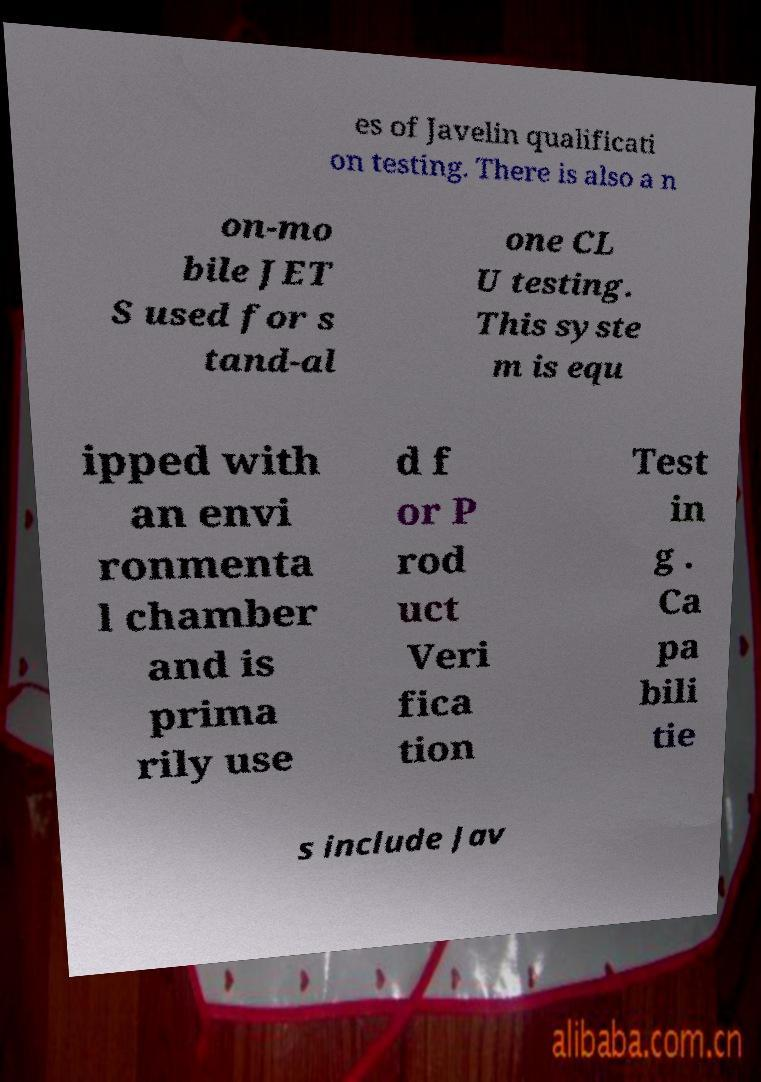Could you assist in decoding the text presented in this image and type it out clearly? es of Javelin qualificati on testing. There is also a n on-mo bile JET S used for s tand-al one CL U testing. This syste m is equ ipped with an envi ronmenta l chamber and is prima rily use d f or P rod uct Veri fica tion Test in g . Ca pa bili tie s include Jav 